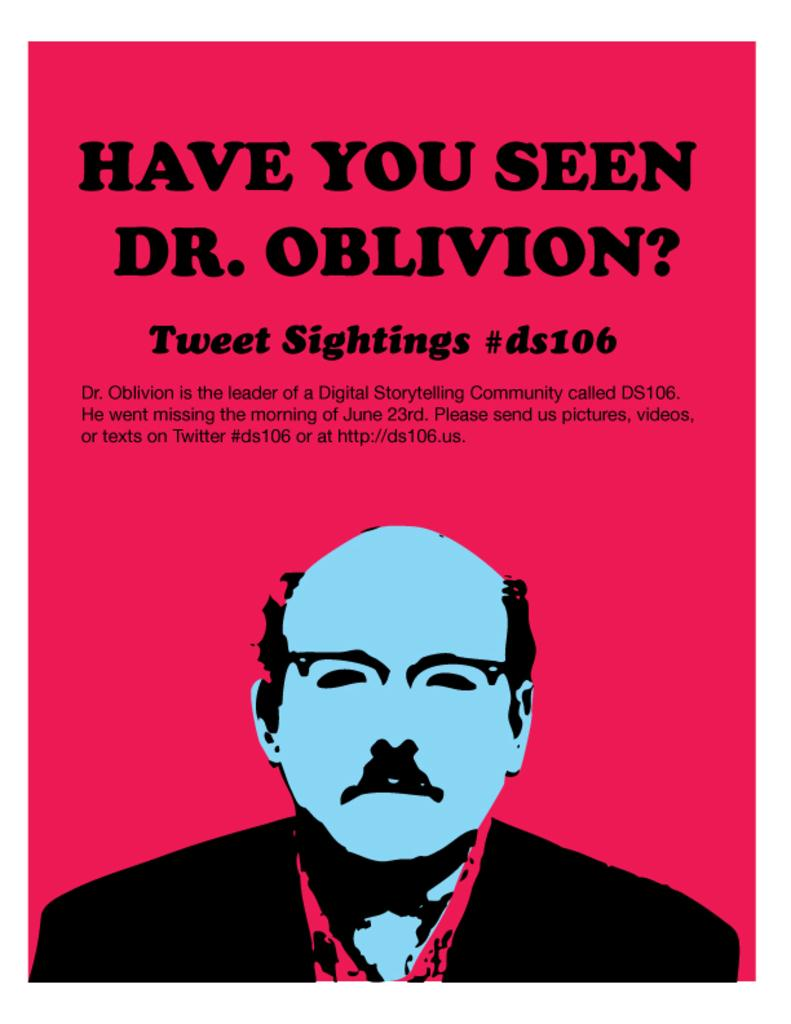Provide a one-sentence caption for the provided image. A red poster asking "Have you seen Dr. Obilvion". 